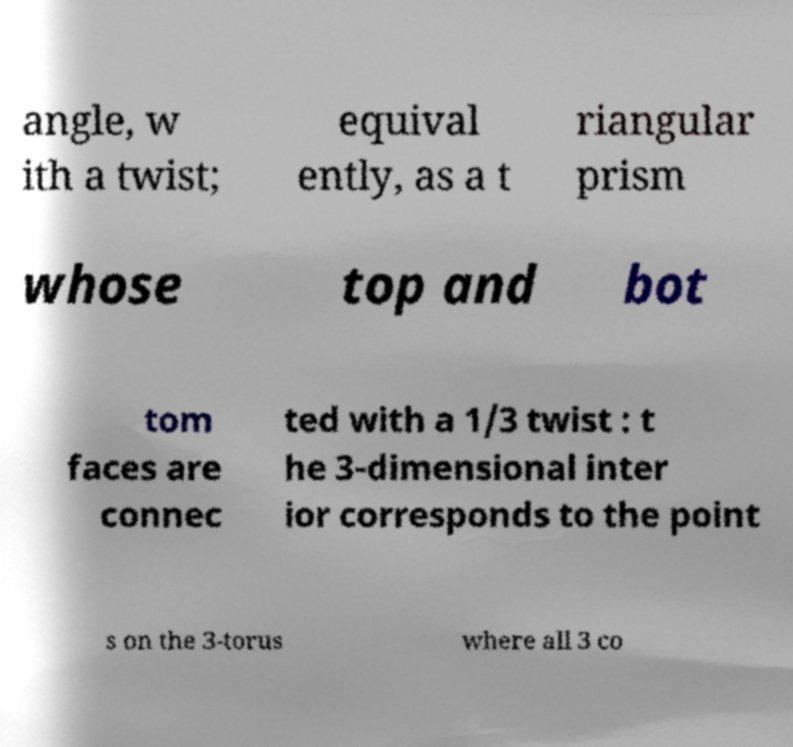Please identify and transcribe the text found in this image. angle, w ith a twist; equival ently, as a t riangular prism whose top and bot tom faces are connec ted with a 1/3 twist : t he 3-dimensional inter ior corresponds to the point s on the 3-torus where all 3 co 